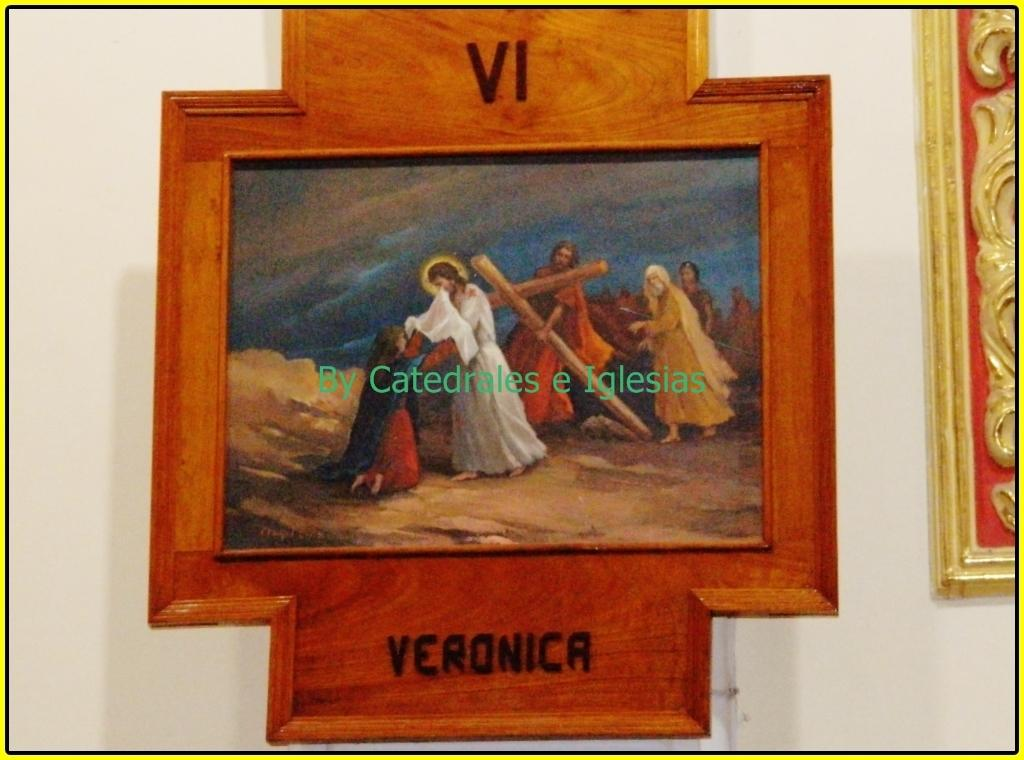<image>
Describe the image concisely. a painting with Veronica written under it in black 